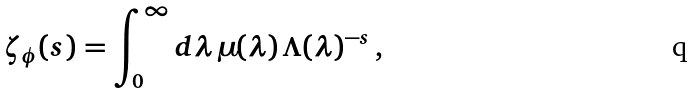Convert formula to latex. <formula><loc_0><loc_0><loc_500><loc_500>\zeta _ { \phi } ( s ) = \int ^ { \infty } _ { 0 } d \lambda \, \mu ( \lambda ) \, \Lambda ( \lambda ) ^ { - s } \, ,</formula> 